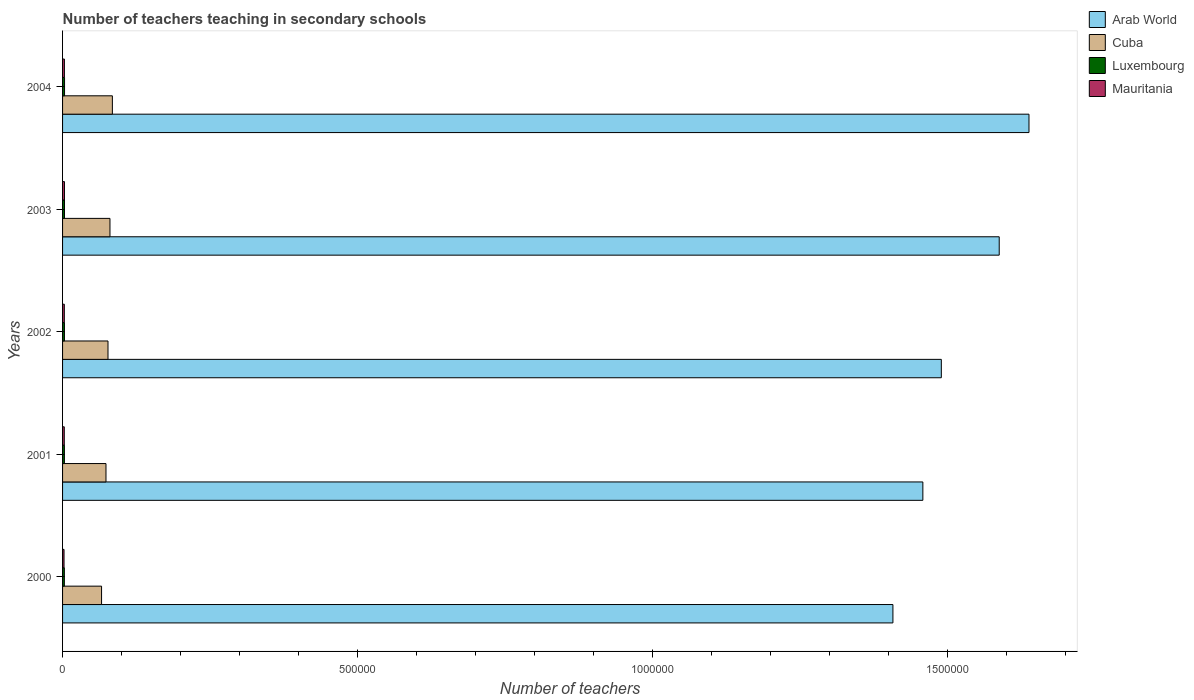Are the number of bars on each tick of the Y-axis equal?
Offer a terse response. Yes. How many bars are there on the 3rd tick from the top?
Give a very brief answer. 4. In how many cases, is the number of bars for a given year not equal to the number of legend labels?
Provide a short and direct response. 0. What is the number of teachers teaching in secondary schools in Arab World in 2002?
Give a very brief answer. 1.49e+06. Across all years, what is the maximum number of teachers teaching in secondary schools in Arab World?
Ensure brevity in your answer.  1.64e+06. Across all years, what is the minimum number of teachers teaching in secondary schools in Cuba?
Ensure brevity in your answer.  6.61e+04. What is the total number of teachers teaching in secondary schools in Cuba in the graph?
Offer a terse response. 3.82e+05. What is the difference between the number of teachers teaching in secondary schools in Cuba in 2000 and that in 2002?
Your response must be concise. -1.09e+04. What is the difference between the number of teachers teaching in secondary schools in Mauritania in 2000 and the number of teachers teaching in secondary schools in Arab World in 2001?
Your answer should be compact. -1.46e+06. What is the average number of teachers teaching in secondary schools in Arab World per year?
Make the answer very short. 1.52e+06. In the year 2000, what is the difference between the number of teachers teaching in secondary schools in Cuba and number of teachers teaching in secondary schools in Arab World?
Keep it short and to the point. -1.34e+06. What is the ratio of the number of teachers teaching in secondary schools in Luxembourg in 2000 to that in 2001?
Offer a very short reply. 0.97. Is the number of teachers teaching in secondary schools in Arab World in 2003 less than that in 2004?
Give a very brief answer. Yes. Is the difference between the number of teachers teaching in secondary schools in Cuba in 2001 and 2002 greater than the difference between the number of teachers teaching in secondary schools in Arab World in 2001 and 2002?
Offer a terse response. Yes. What is the difference between the highest and the second highest number of teachers teaching in secondary schools in Arab World?
Make the answer very short. 5.05e+04. What is the difference between the highest and the lowest number of teachers teaching in secondary schools in Cuba?
Ensure brevity in your answer.  1.83e+04. Is the sum of the number of teachers teaching in secondary schools in Luxembourg in 2000 and 2003 greater than the maximum number of teachers teaching in secondary schools in Arab World across all years?
Provide a succinct answer. No. What does the 4th bar from the top in 2001 represents?
Make the answer very short. Arab World. What does the 1st bar from the bottom in 2004 represents?
Your response must be concise. Arab World. How many bars are there?
Keep it short and to the point. 20. Are all the bars in the graph horizontal?
Give a very brief answer. Yes. How many years are there in the graph?
Your response must be concise. 5. What is the difference between two consecutive major ticks on the X-axis?
Give a very brief answer. 5.00e+05. Does the graph contain grids?
Keep it short and to the point. No. Where does the legend appear in the graph?
Offer a terse response. Top right. How are the legend labels stacked?
Your answer should be compact. Vertical. What is the title of the graph?
Provide a succinct answer. Number of teachers teaching in secondary schools. Does "Algeria" appear as one of the legend labels in the graph?
Make the answer very short. No. What is the label or title of the X-axis?
Offer a very short reply. Number of teachers. What is the label or title of the Y-axis?
Keep it short and to the point. Years. What is the Number of teachers in Arab World in 2000?
Your answer should be very brief. 1.41e+06. What is the Number of teachers in Cuba in 2000?
Offer a terse response. 6.61e+04. What is the Number of teachers in Luxembourg in 2000?
Your response must be concise. 3031. What is the Number of teachers in Mauritania in 2000?
Offer a terse response. 2492. What is the Number of teachers in Arab World in 2001?
Provide a short and direct response. 1.46e+06. What is the Number of teachers of Cuba in 2001?
Your response must be concise. 7.36e+04. What is the Number of teachers in Luxembourg in 2001?
Your answer should be very brief. 3125. What is the Number of teachers of Mauritania in 2001?
Offer a very short reply. 2911. What is the Number of teachers in Arab World in 2002?
Ensure brevity in your answer.  1.49e+06. What is the Number of teachers of Cuba in 2002?
Keep it short and to the point. 7.70e+04. What is the Number of teachers in Luxembourg in 2002?
Provide a short and direct response. 3206. What is the Number of teachers in Mauritania in 2002?
Provide a short and direct response. 3000. What is the Number of teachers of Arab World in 2003?
Your answer should be compact. 1.59e+06. What is the Number of teachers in Cuba in 2003?
Keep it short and to the point. 8.04e+04. What is the Number of teachers in Luxembourg in 2003?
Your response must be concise. 3279. What is the Number of teachers of Mauritania in 2003?
Ensure brevity in your answer.  3237. What is the Number of teachers of Arab World in 2004?
Make the answer very short. 1.64e+06. What is the Number of teachers of Cuba in 2004?
Ensure brevity in your answer.  8.45e+04. What is the Number of teachers of Luxembourg in 2004?
Your answer should be very brief. 3359. What is the Number of teachers in Mauritania in 2004?
Your response must be concise. 3126. Across all years, what is the maximum Number of teachers of Arab World?
Ensure brevity in your answer.  1.64e+06. Across all years, what is the maximum Number of teachers in Cuba?
Provide a succinct answer. 8.45e+04. Across all years, what is the maximum Number of teachers of Luxembourg?
Your answer should be very brief. 3359. Across all years, what is the maximum Number of teachers of Mauritania?
Make the answer very short. 3237. Across all years, what is the minimum Number of teachers in Arab World?
Offer a terse response. 1.41e+06. Across all years, what is the minimum Number of teachers in Cuba?
Your response must be concise. 6.61e+04. Across all years, what is the minimum Number of teachers of Luxembourg?
Ensure brevity in your answer.  3031. Across all years, what is the minimum Number of teachers of Mauritania?
Your answer should be compact. 2492. What is the total Number of teachers in Arab World in the graph?
Offer a terse response. 7.58e+06. What is the total Number of teachers of Cuba in the graph?
Offer a terse response. 3.82e+05. What is the total Number of teachers of Luxembourg in the graph?
Ensure brevity in your answer.  1.60e+04. What is the total Number of teachers in Mauritania in the graph?
Keep it short and to the point. 1.48e+04. What is the difference between the Number of teachers in Arab World in 2000 and that in 2001?
Give a very brief answer. -5.08e+04. What is the difference between the Number of teachers of Cuba in 2000 and that in 2001?
Give a very brief answer. -7505. What is the difference between the Number of teachers of Luxembourg in 2000 and that in 2001?
Your answer should be compact. -94. What is the difference between the Number of teachers in Mauritania in 2000 and that in 2001?
Provide a short and direct response. -419. What is the difference between the Number of teachers in Arab World in 2000 and that in 2002?
Offer a terse response. -8.21e+04. What is the difference between the Number of teachers of Cuba in 2000 and that in 2002?
Your answer should be compact. -1.09e+04. What is the difference between the Number of teachers in Luxembourg in 2000 and that in 2002?
Give a very brief answer. -175. What is the difference between the Number of teachers of Mauritania in 2000 and that in 2002?
Provide a short and direct response. -508. What is the difference between the Number of teachers of Arab World in 2000 and that in 2003?
Give a very brief answer. -1.80e+05. What is the difference between the Number of teachers of Cuba in 2000 and that in 2003?
Keep it short and to the point. -1.42e+04. What is the difference between the Number of teachers of Luxembourg in 2000 and that in 2003?
Offer a terse response. -248. What is the difference between the Number of teachers in Mauritania in 2000 and that in 2003?
Make the answer very short. -745. What is the difference between the Number of teachers of Arab World in 2000 and that in 2004?
Offer a very short reply. -2.31e+05. What is the difference between the Number of teachers of Cuba in 2000 and that in 2004?
Offer a terse response. -1.83e+04. What is the difference between the Number of teachers of Luxembourg in 2000 and that in 2004?
Your answer should be very brief. -328. What is the difference between the Number of teachers of Mauritania in 2000 and that in 2004?
Offer a terse response. -634. What is the difference between the Number of teachers in Arab World in 2001 and that in 2002?
Offer a very short reply. -3.13e+04. What is the difference between the Number of teachers of Cuba in 2001 and that in 2002?
Offer a terse response. -3414. What is the difference between the Number of teachers of Luxembourg in 2001 and that in 2002?
Make the answer very short. -81. What is the difference between the Number of teachers of Mauritania in 2001 and that in 2002?
Give a very brief answer. -89. What is the difference between the Number of teachers of Arab World in 2001 and that in 2003?
Your answer should be very brief. -1.29e+05. What is the difference between the Number of teachers of Cuba in 2001 and that in 2003?
Your answer should be compact. -6745. What is the difference between the Number of teachers in Luxembourg in 2001 and that in 2003?
Offer a terse response. -154. What is the difference between the Number of teachers in Mauritania in 2001 and that in 2003?
Keep it short and to the point. -326. What is the difference between the Number of teachers in Arab World in 2001 and that in 2004?
Offer a terse response. -1.80e+05. What is the difference between the Number of teachers of Cuba in 2001 and that in 2004?
Ensure brevity in your answer.  -1.08e+04. What is the difference between the Number of teachers of Luxembourg in 2001 and that in 2004?
Your response must be concise. -234. What is the difference between the Number of teachers in Mauritania in 2001 and that in 2004?
Your answer should be very brief. -215. What is the difference between the Number of teachers in Arab World in 2002 and that in 2003?
Keep it short and to the point. -9.82e+04. What is the difference between the Number of teachers in Cuba in 2002 and that in 2003?
Give a very brief answer. -3331. What is the difference between the Number of teachers in Luxembourg in 2002 and that in 2003?
Make the answer very short. -73. What is the difference between the Number of teachers in Mauritania in 2002 and that in 2003?
Give a very brief answer. -237. What is the difference between the Number of teachers in Arab World in 2002 and that in 2004?
Your answer should be very brief. -1.49e+05. What is the difference between the Number of teachers in Cuba in 2002 and that in 2004?
Keep it short and to the point. -7426. What is the difference between the Number of teachers of Luxembourg in 2002 and that in 2004?
Your answer should be compact. -153. What is the difference between the Number of teachers of Mauritania in 2002 and that in 2004?
Provide a short and direct response. -126. What is the difference between the Number of teachers of Arab World in 2003 and that in 2004?
Keep it short and to the point. -5.05e+04. What is the difference between the Number of teachers of Cuba in 2003 and that in 2004?
Your answer should be compact. -4095. What is the difference between the Number of teachers of Luxembourg in 2003 and that in 2004?
Keep it short and to the point. -80. What is the difference between the Number of teachers in Mauritania in 2003 and that in 2004?
Give a very brief answer. 111. What is the difference between the Number of teachers of Arab World in 2000 and the Number of teachers of Cuba in 2001?
Ensure brevity in your answer.  1.33e+06. What is the difference between the Number of teachers in Arab World in 2000 and the Number of teachers in Luxembourg in 2001?
Give a very brief answer. 1.40e+06. What is the difference between the Number of teachers of Arab World in 2000 and the Number of teachers of Mauritania in 2001?
Your answer should be very brief. 1.41e+06. What is the difference between the Number of teachers in Cuba in 2000 and the Number of teachers in Luxembourg in 2001?
Offer a terse response. 6.30e+04. What is the difference between the Number of teachers in Cuba in 2000 and the Number of teachers in Mauritania in 2001?
Make the answer very short. 6.32e+04. What is the difference between the Number of teachers in Luxembourg in 2000 and the Number of teachers in Mauritania in 2001?
Make the answer very short. 120. What is the difference between the Number of teachers of Arab World in 2000 and the Number of teachers of Cuba in 2002?
Provide a succinct answer. 1.33e+06. What is the difference between the Number of teachers of Arab World in 2000 and the Number of teachers of Luxembourg in 2002?
Offer a terse response. 1.40e+06. What is the difference between the Number of teachers in Arab World in 2000 and the Number of teachers in Mauritania in 2002?
Your answer should be compact. 1.40e+06. What is the difference between the Number of teachers in Cuba in 2000 and the Number of teachers in Luxembourg in 2002?
Your response must be concise. 6.29e+04. What is the difference between the Number of teachers of Cuba in 2000 and the Number of teachers of Mauritania in 2002?
Your answer should be very brief. 6.31e+04. What is the difference between the Number of teachers of Luxembourg in 2000 and the Number of teachers of Mauritania in 2002?
Offer a very short reply. 31. What is the difference between the Number of teachers of Arab World in 2000 and the Number of teachers of Cuba in 2003?
Ensure brevity in your answer.  1.33e+06. What is the difference between the Number of teachers of Arab World in 2000 and the Number of teachers of Luxembourg in 2003?
Give a very brief answer. 1.40e+06. What is the difference between the Number of teachers of Arab World in 2000 and the Number of teachers of Mauritania in 2003?
Give a very brief answer. 1.40e+06. What is the difference between the Number of teachers in Cuba in 2000 and the Number of teachers in Luxembourg in 2003?
Give a very brief answer. 6.28e+04. What is the difference between the Number of teachers of Cuba in 2000 and the Number of teachers of Mauritania in 2003?
Provide a succinct answer. 6.29e+04. What is the difference between the Number of teachers in Luxembourg in 2000 and the Number of teachers in Mauritania in 2003?
Your response must be concise. -206. What is the difference between the Number of teachers of Arab World in 2000 and the Number of teachers of Cuba in 2004?
Provide a short and direct response. 1.32e+06. What is the difference between the Number of teachers of Arab World in 2000 and the Number of teachers of Luxembourg in 2004?
Give a very brief answer. 1.40e+06. What is the difference between the Number of teachers in Arab World in 2000 and the Number of teachers in Mauritania in 2004?
Your response must be concise. 1.40e+06. What is the difference between the Number of teachers of Cuba in 2000 and the Number of teachers of Luxembourg in 2004?
Offer a very short reply. 6.28e+04. What is the difference between the Number of teachers of Cuba in 2000 and the Number of teachers of Mauritania in 2004?
Your answer should be very brief. 6.30e+04. What is the difference between the Number of teachers of Luxembourg in 2000 and the Number of teachers of Mauritania in 2004?
Ensure brevity in your answer.  -95. What is the difference between the Number of teachers in Arab World in 2001 and the Number of teachers in Cuba in 2002?
Your answer should be very brief. 1.38e+06. What is the difference between the Number of teachers in Arab World in 2001 and the Number of teachers in Luxembourg in 2002?
Offer a very short reply. 1.46e+06. What is the difference between the Number of teachers in Arab World in 2001 and the Number of teachers in Mauritania in 2002?
Give a very brief answer. 1.46e+06. What is the difference between the Number of teachers of Cuba in 2001 and the Number of teachers of Luxembourg in 2002?
Provide a short and direct response. 7.04e+04. What is the difference between the Number of teachers in Cuba in 2001 and the Number of teachers in Mauritania in 2002?
Your answer should be compact. 7.06e+04. What is the difference between the Number of teachers in Luxembourg in 2001 and the Number of teachers in Mauritania in 2002?
Your response must be concise. 125. What is the difference between the Number of teachers in Arab World in 2001 and the Number of teachers in Cuba in 2003?
Make the answer very short. 1.38e+06. What is the difference between the Number of teachers in Arab World in 2001 and the Number of teachers in Luxembourg in 2003?
Keep it short and to the point. 1.46e+06. What is the difference between the Number of teachers in Arab World in 2001 and the Number of teachers in Mauritania in 2003?
Your response must be concise. 1.46e+06. What is the difference between the Number of teachers of Cuba in 2001 and the Number of teachers of Luxembourg in 2003?
Offer a terse response. 7.03e+04. What is the difference between the Number of teachers of Cuba in 2001 and the Number of teachers of Mauritania in 2003?
Make the answer very short. 7.04e+04. What is the difference between the Number of teachers of Luxembourg in 2001 and the Number of teachers of Mauritania in 2003?
Make the answer very short. -112. What is the difference between the Number of teachers in Arab World in 2001 and the Number of teachers in Cuba in 2004?
Ensure brevity in your answer.  1.37e+06. What is the difference between the Number of teachers of Arab World in 2001 and the Number of teachers of Luxembourg in 2004?
Your answer should be very brief. 1.46e+06. What is the difference between the Number of teachers of Arab World in 2001 and the Number of teachers of Mauritania in 2004?
Offer a terse response. 1.46e+06. What is the difference between the Number of teachers in Cuba in 2001 and the Number of teachers in Luxembourg in 2004?
Provide a succinct answer. 7.03e+04. What is the difference between the Number of teachers of Cuba in 2001 and the Number of teachers of Mauritania in 2004?
Keep it short and to the point. 7.05e+04. What is the difference between the Number of teachers of Luxembourg in 2001 and the Number of teachers of Mauritania in 2004?
Provide a short and direct response. -1. What is the difference between the Number of teachers of Arab World in 2002 and the Number of teachers of Cuba in 2003?
Offer a terse response. 1.41e+06. What is the difference between the Number of teachers in Arab World in 2002 and the Number of teachers in Luxembourg in 2003?
Your answer should be compact. 1.49e+06. What is the difference between the Number of teachers of Arab World in 2002 and the Number of teachers of Mauritania in 2003?
Offer a very short reply. 1.49e+06. What is the difference between the Number of teachers in Cuba in 2002 and the Number of teachers in Luxembourg in 2003?
Provide a succinct answer. 7.38e+04. What is the difference between the Number of teachers in Cuba in 2002 and the Number of teachers in Mauritania in 2003?
Give a very brief answer. 7.38e+04. What is the difference between the Number of teachers of Luxembourg in 2002 and the Number of teachers of Mauritania in 2003?
Provide a short and direct response. -31. What is the difference between the Number of teachers of Arab World in 2002 and the Number of teachers of Cuba in 2004?
Offer a terse response. 1.41e+06. What is the difference between the Number of teachers of Arab World in 2002 and the Number of teachers of Luxembourg in 2004?
Keep it short and to the point. 1.49e+06. What is the difference between the Number of teachers in Arab World in 2002 and the Number of teachers in Mauritania in 2004?
Provide a succinct answer. 1.49e+06. What is the difference between the Number of teachers of Cuba in 2002 and the Number of teachers of Luxembourg in 2004?
Keep it short and to the point. 7.37e+04. What is the difference between the Number of teachers of Cuba in 2002 and the Number of teachers of Mauritania in 2004?
Make the answer very short. 7.39e+04. What is the difference between the Number of teachers in Arab World in 2003 and the Number of teachers in Cuba in 2004?
Ensure brevity in your answer.  1.50e+06. What is the difference between the Number of teachers in Arab World in 2003 and the Number of teachers in Luxembourg in 2004?
Give a very brief answer. 1.58e+06. What is the difference between the Number of teachers in Arab World in 2003 and the Number of teachers in Mauritania in 2004?
Make the answer very short. 1.59e+06. What is the difference between the Number of teachers of Cuba in 2003 and the Number of teachers of Luxembourg in 2004?
Make the answer very short. 7.70e+04. What is the difference between the Number of teachers of Cuba in 2003 and the Number of teachers of Mauritania in 2004?
Make the answer very short. 7.72e+04. What is the difference between the Number of teachers of Luxembourg in 2003 and the Number of teachers of Mauritania in 2004?
Your response must be concise. 153. What is the average Number of teachers of Arab World per year?
Offer a very short reply. 1.52e+06. What is the average Number of teachers of Cuba per year?
Give a very brief answer. 7.63e+04. What is the average Number of teachers in Luxembourg per year?
Ensure brevity in your answer.  3200. What is the average Number of teachers of Mauritania per year?
Provide a short and direct response. 2953.2. In the year 2000, what is the difference between the Number of teachers of Arab World and Number of teachers of Cuba?
Provide a succinct answer. 1.34e+06. In the year 2000, what is the difference between the Number of teachers of Arab World and Number of teachers of Luxembourg?
Your answer should be very brief. 1.40e+06. In the year 2000, what is the difference between the Number of teachers of Arab World and Number of teachers of Mauritania?
Give a very brief answer. 1.41e+06. In the year 2000, what is the difference between the Number of teachers of Cuba and Number of teachers of Luxembourg?
Provide a short and direct response. 6.31e+04. In the year 2000, what is the difference between the Number of teachers of Cuba and Number of teachers of Mauritania?
Your answer should be very brief. 6.36e+04. In the year 2000, what is the difference between the Number of teachers of Luxembourg and Number of teachers of Mauritania?
Your response must be concise. 539. In the year 2001, what is the difference between the Number of teachers of Arab World and Number of teachers of Cuba?
Provide a succinct answer. 1.39e+06. In the year 2001, what is the difference between the Number of teachers of Arab World and Number of teachers of Luxembourg?
Make the answer very short. 1.46e+06. In the year 2001, what is the difference between the Number of teachers of Arab World and Number of teachers of Mauritania?
Provide a succinct answer. 1.46e+06. In the year 2001, what is the difference between the Number of teachers of Cuba and Number of teachers of Luxembourg?
Provide a succinct answer. 7.05e+04. In the year 2001, what is the difference between the Number of teachers in Cuba and Number of teachers in Mauritania?
Your answer should be very brief. 7.07e+04. In the year 2001, what is the difference between the Number of teachers in Luxembourg and Number of teachers in Mauritania?
Make the answer very short. 214. In the year 2002, what is the difference between the Number of teachers of Arab World and Number of teachers of Cuba?
Your answer should be compact. 1.41e+06. In the year 2002, what is the difference between the Number of teachers of Arab World and Number of teachers of Luxembourg?
Keep it short and to the point. 1.49e+06. In the year 2002, what is the difference between the Number of teachers in Arab World and Number of teachers in Mauritania?
Give a very brief answer. 1.49e+06. In the year 2002, what is the difference between the Number of teachers of Cuba and Number of teachers of Luxembourg?
Your response must be concise. 7.38e+04. In the year 2002, what is the difference between the Number of teachers of Cuba and Number of teachers of Mauritania?
Your answer should be very brief. 7.40e+04. In the year 2002, what is the difference between the Number of teachers of Luxembourg and Number of teachers of Mauritania?
Your response must be concise. 206. In the year 2003, what is the difference between the Number of teachers of Arab World and Number of teachers of Cuba?
Offer a very short reply. 1.51e+06. In the year 2003, what is the difference between the Number of teachers in Arab World and Number of teachers in Luxembourg?
Your response must be concise. 1.58e+06. In the year 2003, what is the difference between the Number of teachers in Arab World and Number of teachers in Mauritania?
Keep it short and to the point. 1.58e+06. In the year 2003, what is the difference between the Number of teachers of Cuba and Number of teachers of Luxembourg?
Give a very brief answer. 7.71e+04. In the year 2003, what is the difference between the Number of teachers in Cuba and Number of teachers in Mauritania?
Give a very brief answer. 7.71e+04. In the year 2004, what is the difference between the Number of teachers in Arab World and Number of teachers in Cuba?
Your answer should be very brief. 1.55e+06. In the year 2004, what is the difference between the Number of teachers of Arab World and Number of teachers of Luxembourg?
Your answer should be very brief. 1.64e+06. In the year 2004, what is the difference between the Number of teachers in Arab World and Number of teachers in Mauritania?
Offer a terse response. 1.64e+06. In the year 2004, what is the difference between the Number of teachers of Cuba and Number of teachers of Luxembourg?
Keep it short and to the point. 8.11e+04. In the year 2004, what is the difference between the Number of teachers in Cuba and Number of teachers in Mauritania?
Provide a short and direct response. 8.13e+04. In the year 2004, what is the difference between the Number of teachers of Luxembourg and Number of teachers of Mauritania?
Your answer should be compact. 233. What is the ratio of the Number of teachers in Arab World in 2000 to that in 2001?
Your answer should be very brief. 0.97. What is the ratio of the Number of teachers of Cuba in 2000 to that in 2001?
Offer a terse response. 0.9. What is the ratio of the Number of teachers in Luxembourg in 2000 to that in 2001?
Ensure brevity in your answer.  0.97. What is the ratio of the Number of teachers of Mauritania in 2000 to that in 2001?
Keep it short and to the point. 0.86. What is the ratio of the Number of teachers of Arab World in 2000 to that in 2002?
Provide a succinct answer. 0.94. What is the ratio of the Number of teachers in Cuba in 2000 to that in 2002?
Your answer should be compact. 0.86. What is the ratio of the Number of teachers of Luxembourg in 2000 to that in 2002?
Give a very brief answer. 0.95. What is the ratio of the Number of teachers in Mauritania in 2000 to that in 2002?
Offer a terse response. 0.83. What is the ratio of the Number of teachers of Arab World in 2000 to that in 2003?
Offer a terse response. 0.89. What is the ratio of the Number of teachers of Cuba in 2000 to that in 2003?
Offer a very short reply. 0.82. What is the ratio of the Number of teachers of Luxembourg in 2000 to that in 2003?
Provide a succinct answer. 0.92. What is the ratio of the Number of teachers in Mauritania in 2000 to that in 2003?
Make the answer very short. 0.77. What is the ratio of the Number of teachers of Arab World in 2000 to that in 2004?
Your response must be concise. 0.86. What is the ratio of the Number of teachers in Cuba in 2000 to that in 2004?
Provide a succinct answer. 0.78. What is the ratio of the Number of teachers in Luxembourg in 2000 to that in 2004?
Your response must be concise. 0.9. What is the ratio of the Number of teachers of Mauritania in 2000 to that in 2004?
Keep it short and to the point. 0.8. What is the ratio of the Number of teachers in Cuba in 2001 to that in 2002?
Your answer should be very brief. 0.96. What is the ratio of the Number of teachers in Luxembourg in 2001 to that in 2002?
Give a very brief answer. 0.97. What is the ratio of the Number of teachers of Mauritania in 2001 to that in 2002?
Your answer should be very brief. 0.97. What is the ratio of the Number of teachers in Arab World in 2001 to that in 2003?
Give a very brief answer. 0.92. What is the ratio of the Number of teachers of Cuba in 2001 to that in 2003?
Provide a succinct answer. 0.92. What is the ratio of the Number of teachers in Luxembourg in 2001 to that in 2003?
Offer a terse response. 0.95. What is the ratio of the Number of teachers of Mauritania in 2001 to that in 2003?
Provide a succinct answer. 0.9. What is the ratio of the Number of teachers in Arab World in 2001 to that in 2004?
Provide a succinct answer. 0.89. What is the ratio of the Number of teachers in Cuba in 2001 to that in 2004?
Ensure brevity in your answer.  0.87. What is the ratio of the Number of teachers of Luxembourg in 2001 to that in 2004?
Provide a succinct answer. 0.93. What is the ratio of the Number of teachers of Mauritania in 2001 to that in 2004?
Offer a very short reply. 0.93. What is the ratio of the Number of teachers in Arab World in 2002 to that in 2003?
Give a very brief answer. 0.94. What is the ratio of the Number of teachers in Cuba in 2002 to that in 2003?
Provide a short and direct response. 0.96. What is the ratio of the Number of teachers of Luxembourg in 2002 to that in 2003?
Ensure brevity in your answer.  0.98. What is the ratio of the Number of teachers of Mauritania in 2002 to that in 2003?
Your answer should be compact. 0.93. What is the ratio of the Number of teachers in Arab World in 2002 to that in 2004?
Provide a short and direct response. 0.91. What is the ratio of the Number of teachers of Cuba in 2002 to that in 2004?
Offer a terse response. 0.91. What is the ratio of the Number of teachers of Luxembourg in 2002 to that in 2004?
Give a very brief answer. 0.95. What is the ratio of the Number of teachers in Mauritania in 2002 to that in 2004?
Your response must be concise. 0.96. What is the ratio of the Number of teachers in Arab World in 2003 to that in 2004?
Make the answer very short. 0.97. What is the ratio of the Number of teachers of Cuba in 2003 to that in 2004?
Provide a succinct answer. 0.95. What is the ratio of the Number of teachers of Luxembourg in 2003 to that in 2004?
Provide a succinct answer. 0.98. What is the ratio of the Number of teachers in Mauritania in 2003 to that in 2004?
Provide a short and direct response. 1.04. What is the difference between the highest and the second highest Number of teachers of Arab World?
Your answer should be compact. 5.05e+04. What is the difference between the highest and the second highest Number of teachers of Cuba?
Offer a very short reply. 4095. What is the difference between the highest and the second highest Number of teachers in Mauritania?
Make the answer very short. 111. What is the difference between the highest and the lowest Number of teachers in Arab World?
Offer a terse response. 2.31e+05. What is the difference between the highest and the lowest Number of teachers in Cuba?
Provide a short and direct response. 1.83e+04. What is the difference between the highest and the lowest Number of teachers in Luxembourg?
Your response must be concise. 328. What is the difference between the highest and the lowest Number of teachers of Mauritania?
Offer a terse response. 745. 